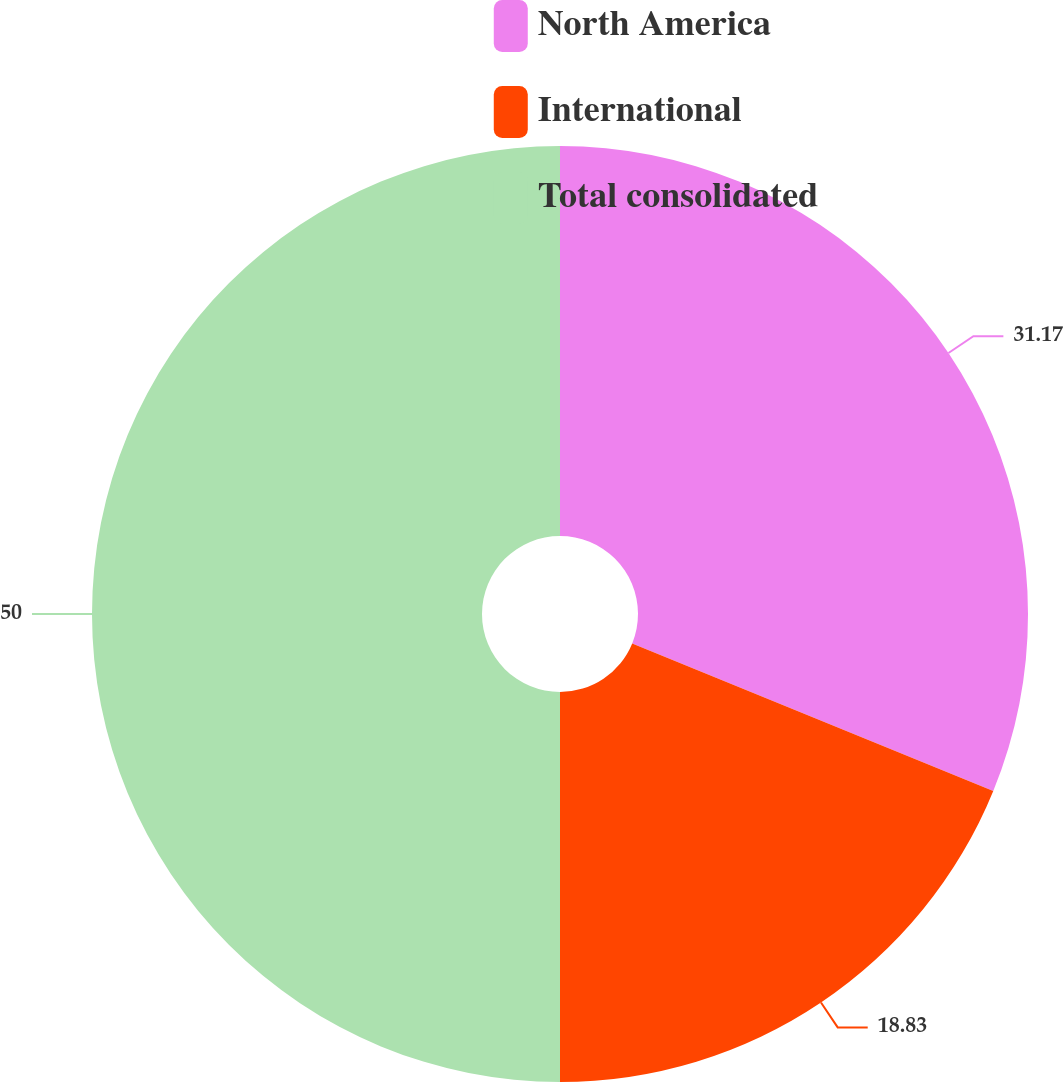<chart> <loc_0><loc_0><loc_500><loc_500><pie_chart><fcel>North America<fcel>International<fcel>Total consolidated<nl><fcel>31.17%<fcel>18.83%<fcel>50.0%<nl></chart> 